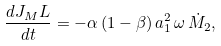<formula> <loc_0><loc_0><loc_500><loc_500>\frac { d J _ { M } L } { d t } = - \alpha \left ( 1 - \beta \right ) a _ { 1 } ^ { 2 } \, \omega \, \dot { M } _ { 2 } ,</formula> 